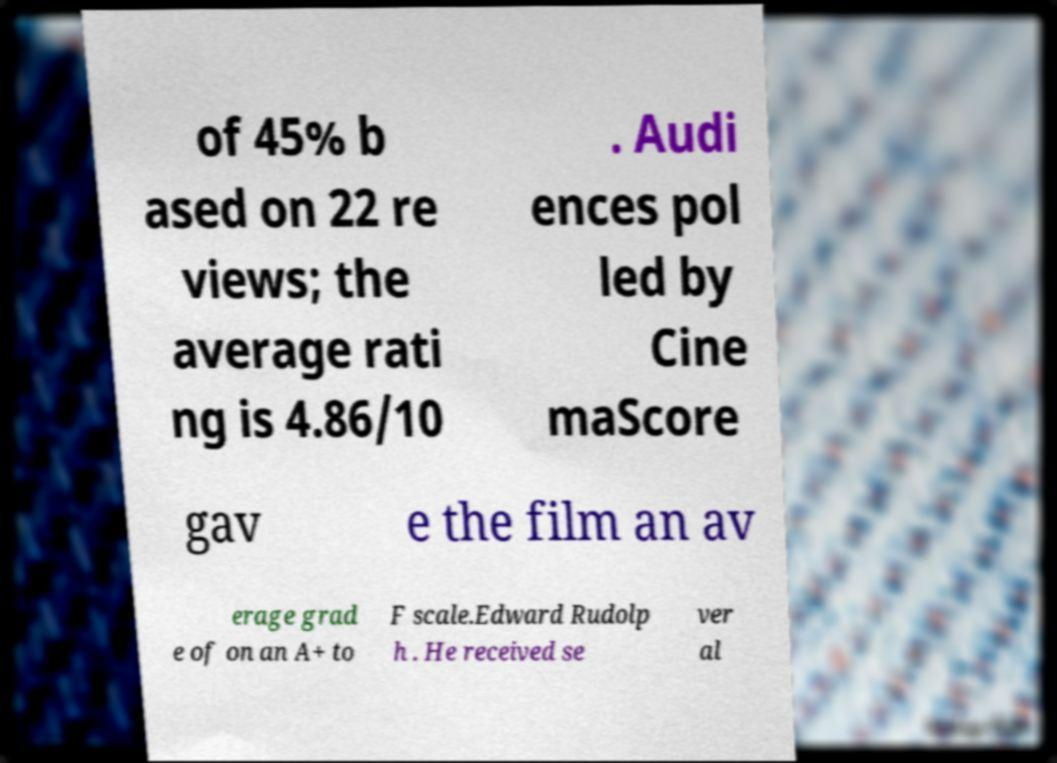There's text embedded in this image that I need extracted. Can you transcribe it verbatim? of 45% b ased on 22 re views; the average rati ng is 4.86/10 . Audi ences pol led by Cine maScore gav e the film an av erage grad e of on an A+ to F scale.Edward Rudolp h . He received se ver al 